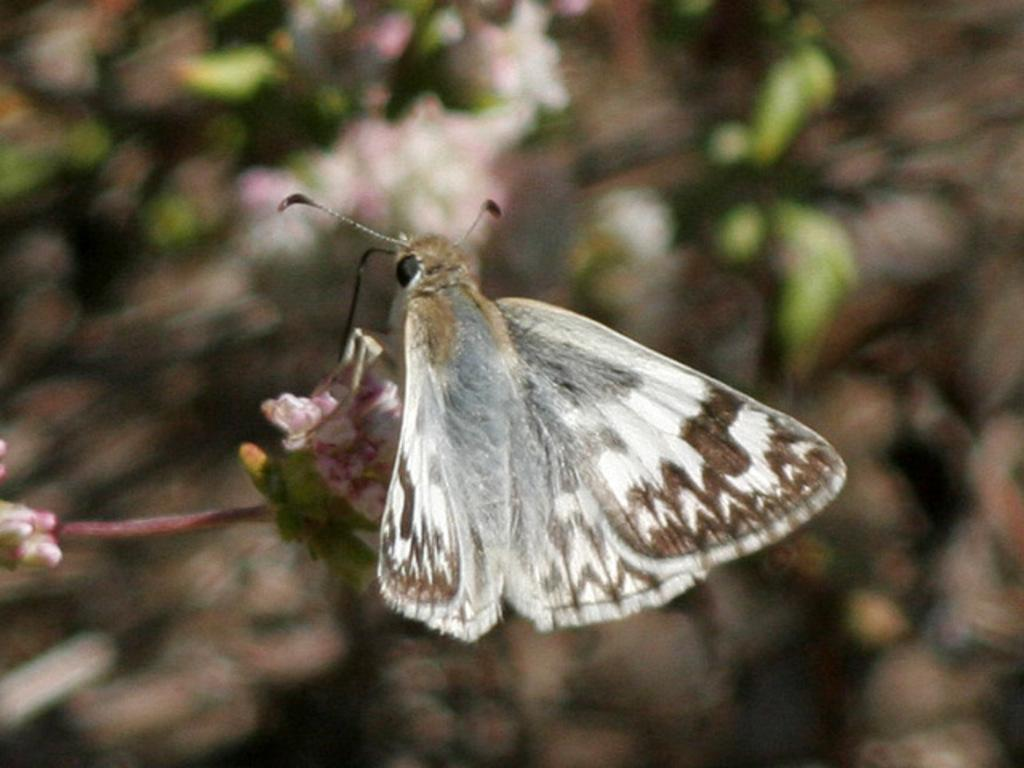What is the main subject of the image? The main subject of the image is a butterfly. Where is the butterfly located in the image? The butterfly is on a flower. What type of cap is the butterfly wearing in the image? There is no cap present on the butterfly in the image. 